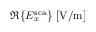Convert formula to latex. <formula><loc_0><loc_0><loc_500><loc_500>\Re \{ E _ { x } ^ { s c a } \} [ V / m ]</formula> 